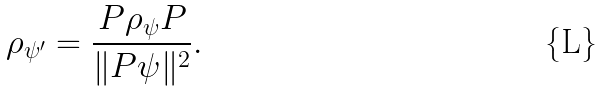<formula> <loc_0><loc_0><loc_500><loc_500>\rho _ { \psi ^ { \prime } } = \frac { P \rho _ { \psi } P } { \| P \psi \| ^ { 2 } } .</formula> 